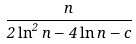<formula> <loc_0><loc_0><loc_500><loc_500>\frac { n } { 2 \ln ^ { 2 } n - 4 \ln n - c }</formula> 